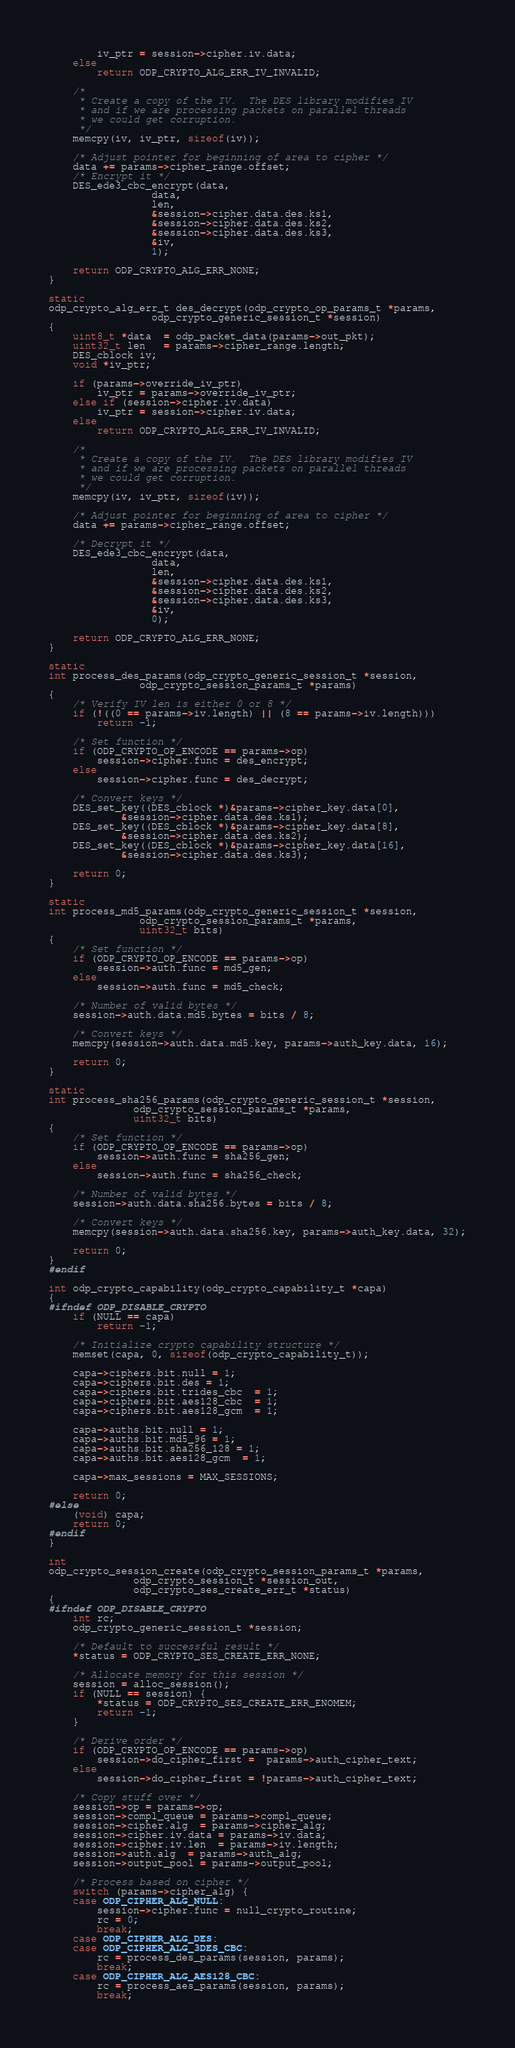<code> <loc_0><loc_0><loc_500><loc_500><_C_>		iv_ptr = session->cipher.iv.data;
	else
		return ODP_CRYPTO_ALG_ERR_IV_INVALID;

	/*
	 * Create a copy of the IV.  The DES library modifies IV
	 * and if we are processing packets on parallel threads
	 * we could get corruption.
	 */
	memcpy(iv, iv_ptr, sizeof(iv));

	/* Adjust pointer for beginning of area to cipher */
	data += params->cipher_range.offset;
	/* Encrypt it */
	DES_ede3_cbc_encrypt(data,
			     data,
			     len,
			     &session->cipher.data.des.ks1,
			     &session->cipher.data.des.ks2,
			     &session->cipher.data.des.ks3,
			     &iv,
			     1);

	return ODP_CRYPTO_ALG_ERR_NONE;
}

static
odp_crypto_alg_err_t des_decrypt(odp_crypto_op_params_t *params,
				 odp_crypto_generic_session_t *session)
{
	uint8_t *data  = odp_packet_data(params->out_pkt);
	uint32_t len   = params->cipher_range.length;
	DES_cblock iv;
	void *iv_ptr;

	if (params->override_iv_ptr)
		iv_ptr = params->override_iv_ptr;
	else if (session->cipher.iv.data)
		iv_ptr = session->cipher.iv.data;
	else
		return ODP_CRYPTO_ALG_ERR_IV_INVALID;

	/*
	 * Create a copy of the IV.  The DES library modifies IV
	 * and if we are processing packets on parallel threads
	 * we could get corruption.
	 */
	memcpy(iv, iv_ptr, sizeof(iv));

	/* Adjust pointer for beginning of area to cipher */
	data += params->cipher_range.offset;

	/* Decrypt it */
	DES_ede3_cbc_encrypt(data,
			     data,
			     len,
			     &session->cipher.data.des.ks1,
			     &session->cipher.data.des.ks2,
			     &session->cipher.data.des.ks3,
			     &iv,
			     0);

	return ODP_CRYPTO_ALG_ERR_NONE;
}

static
int process_des_params(odp_crypto_generic_session_t *session,
		       odp_crypto_session_params_t *params)
{
	/* Verify IV len is either 0 or 8 */
	if (!((0 == params->iv.length) || (8 == params->iv.length)))
		return -1;

	/* Set function */
	if (ODP_CRYPTO_OP_ENCODE == params->op)
		session->cipher.func = des_encrypt;
	else
		session->cipher.func = des_decrypt;

	/* Convert keys */
	DES_set_key((DES_cblock *)&params->cipher_key.data[0],
		    &session->cipher.data.des.ks1);
	DES_set_key((DES_cblock *)&params->cipher_key.data[8],
		    &session->cipher.data.des.ks2);
	DES_set_key((DES_cblock *)&params->cipher_key.data[16],
		    &session->cipher.data.des.ks3);

	return 0;
}

static
int process_md5_params(odp_crypto_generic_session_t *session,
		       odp_crypto_session_params_t *params,
		       uint32_t bits)
{
	/* Set function */
	if (ODP_CRYPTO_OP_ENCODE == params->op)
		session->auth.func = md5_gen;
	else
		session->auth.func = md5_check;

	/* Number of valid bytes */
	session->auth.data.md5.bytes = bits / 8;

	/* Convert keys */
	memcpy(session->auth.data.md5.key, params->auth_key.data, 16);

	return 0;
}

static
int process_sha256_params(odp_crypto_generic_session_t *session,
			  odp_crypto_session_params_t *params,
			  uint32_t bits)
{
	/* Set function */
	if (ODP_CRYPTO_OP_ENCODE == params->op)
		session->auth.func = sha256_gen;
	else
		session->auth.func = sha256_check;

	/* Number of valid bytes */
	session->auth.data.sha256.bytes = bits / 8;

	/* Convert keys */
	memcpy(session->auth.data.sha256.key, params->auth_key.data, 32);

	return 0;
}
#endif

int odp_crypto_capability(odp_crypto_capability_t *capa)
{
#ifndef ODP_DISABLE_CRYPTO
	if (NULL == capa)
		return -1;

	/* Initialize crypto capability structure */
	memset(capa, 0, sizeof(odp_crypto_capability_t));

	capa->ciphers.bit.null = 1;
	capa->ciphers.bit.des = 1;
	capa->ciphers.bit.trides_cbc  = 1;
	capa->ciphers.bit.aes128_cbc  = 1;
	capa->ciphers.bit.aes128_gcm  = 1;

	capa->auths.bit.null = 1;
	capa->auths.bit.md5_96 = 1;
	capa->auths.bit.sha256_128 = 1;
	capa->auths.bit.aes128_gcm  = 1;

	capa->max_sessions = MAX_SESSIONS;

	return 0;
#else
	(void) capa;
	return 0;
#endif
}

int
odp_crypto_session_create(odp_crypto_session_params_t *params,
			  odp_crypto_session_t *session_out,
			  odp_crypto_ses_create_err_t *status)
{
#ifndef ODP_DISABLE_CRYPTO
	int rc;
	odp_crypto_generic_session_t *session;

	/* Default to successful result */
	*status = ODP_CRYPTO_SES_CREATE_ERR_NONE;

	/* Allocate memory for this session */
	session = alloc_session();
	if (NULL == session) {
		*status = ODP_CRYPTO_SES_CREATE_ERR_ENOMEM;
		return -1;
	}

	/* Derive order */
	if (ODP_CRYPTO_OP_ENCODE == params->op)
		session->do_cipher_first =  params->auth_cipher_text;
	else
		session->do_cipher_first = !params->auth_cipher_text;

	/* Copy stuff over */
	session->op = params->op;
	session->compl_queue = params->compl_queue;
	session->cipher.alg  = params->cipher_alg;
	session->cipher.iv.data = params->iv.data;
	session->cipher.iv.len  = params->iv.length;
	session->auth.alg  = params->auth_alg;
	session->output_pool = params->output_pool;

	/* Process based on cipher */
	switch (params->cipher_alg) {
	case ODP_CIPHER_ALG_NULL:
		session->cipher.func = null_crypto_routine;
		rc = 0;
		break;
	case ODP_CIPHER_ALG_DES:
	case ODP_CIPHER_ALG_3DES_CBC:
		rc = process_des_params(session, params);
		break;
	case ODP_CIPHER_ALG_AES128_CBC:
		rc = process_aes_params(session, params);
		break;</code> 